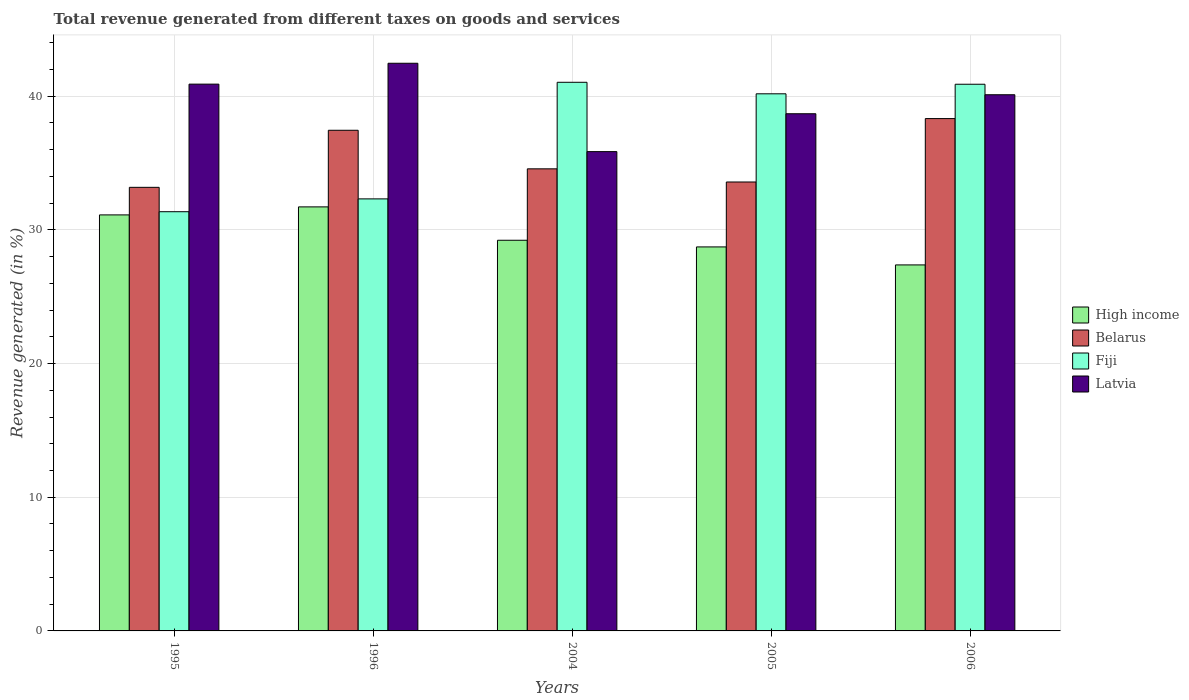How many groups of bars are there?
Make the answer very short. 5. How many bars are there on the 1st tick from the left?
Your answer should be compact. 4. How many bars are there on the 1st tick from the right?
Offer a terse response. 4. What is the total revenue generated in Latvia in 1995?
Ensure brevity in your answer.  40.9. Across all years, what is the maximum total revenue generated in High income?
Give a very brief answer. 31.72. Across all years, what is the minimum total revenue generated in Belarus?
Your answer should be very brief. 33.18. In which year was the total revenue generated in High income minimum?
Your answer should be very brief. 2006. What is the total total revenue generated in Belarus in the graph?
Offer a terse response. 177.1. What is the difference between the total revenue generated in Belarus in 1996 and that in 2006?
Provide a succinct answer. -0.88. What is the difference between the total revenue generated in Belarus in 1996 and the total revenue generated in Latvia in 2004?
Give a very brief answer. 1.6. What is the average total revenue generated in Belarus per year?
Your response must be concise. 35.42. In the year 2006, what is the difference between the total revenue generated in Latvia and total revenue generated in Fiji?
Your answer should be very brief. -0.79. In how many years, is the total revenue generated in High income greater than 6 %?
Ensure brevity in your answer.  5. What is the ratio of the total revenue generated in Fiji in 2005 to that in 2006?
Your answer should be very brief. 0.98. Is the total revenue generated in High income in 1995 less than that in 1996?
Ensure brevity in your answer.  Yes. Is the difference between the total revenue generated in Latvia in 2005 and 2006 greater than the difference between the total revenue generated in Fiji in 2005 and 2006?
Ensure brevity in your answer.  No. What is the difference between the highest and the second highest total revenue generated in Fiji?
Provide a succinct answer. 0.15. What is the difference between the highest and the lowest total revenue generated in High income?
Your response must be concise. 4.34. What does the 4th bar from the left in 1996 represents?
Give a very brief answer. Latvia. What does the 2nd bar from the right in 2004 represents?
Offer a terse response. Fiji. Is it the case that in every year, the sum of the total revenue generated in Fiji and total revenue generated in Latvia is greater than the total revenue generated in High income?
Offer a very short reply. Yes. How many bars are there?
Ensure brevity in your answer.  20. How many years are there in the graph?
Ensure brevity in your answer.  5. What is the difference between two consecutive major ticks on the Y-axis?
Offer a terse response. 10. Where does the legend appear in the graph?
Give a very brief answer. Center right. How many legend labels are there?
Provide a short and direct response. 4. What is the title of the graph?
Keep it short and to the point. Total revenue generated from different taxes on goods and services. Does "Greenland" appear as one of the legend labels in the graph?
Offer a terse response. No. What is the label or title of the Y-axis?
Make the answer very short. Revenue generated (in %). What is the Revenue generated (in %) of High income in 1995?
Provide a short and direct response. 31.12. What is the Revenue generated (in %) of Belarus in 1995?
Give a very brief answer. 33.18. What is the Revenue generated (in %) of Fiji in 1995?
Give a very brief answer. 31.36. What is the Revenue generated (in %) in Latvia in 1995?
Your answer should be compact. 40.9. What is the Revenue generated (in %) of High income in 1996?
Make the answer very short. 31.72. What is the Revenue generated (in %) in Belarus in 1996?
Your answer should be compact. 37.45. What is the Revenue generated (in %) of Fiji in 1996?
Your response must be concise. 32.32. What is the Revenue generated (in %) in Latvia in 1996?
Your response must be concise. 42.46. What is the Revenue generated (in %) in High income in 2004?
Make the answer very short. 29.22. What is the Revenue generated (in %) of Belarus in 2004?
Keep it short and to the point. 34.56. What is the Revenue generated (in %) in Fiji in 2004?
Your answer should be very brief. 41.04. What is the Revenue generated (in %) of Latvia in 2004?
Keep it short and to the point. 35.85. What is the Revenue generated (in %) of High income in 2005?
Provide a short and direct response. 28.72. What is the Revenue generated (in %) in Belarus in 2005?
Offer a very short reply. 33.58. What is the Revenue generated (in %) of Fiji in 2005?
Make the answer very short. 40.18. What is the Revenue generated (in %) of Latvia in 2005?
Make the answer very short. 38.69. What is the Revenue generated (in %) of High income in 2006?
Provide a succinct answer. 27.38. What is the Revenue generated (in %) of Belarus in 2006?
Provide a succinct answer. 38.32. What is the Revenue generated (in %) of Fiji in 2006?
Provide a succinct answer. 40.89. What is the Revenue generated (in %) in Latvia in 2006?
Your answer should be very brief. 40.11. Across all years, what is the maximum Revenue generated (in %) of High income?
Your answer should be very brief. 31.72. Across all years, what is the maximum Revenue generated (in %) of Belarus?
Offer a terse response. 38.32. Across all years, what is the maximum Revenue generated (in %) of Fiji?
Make the answer very short. 41.04. Across all years, what is the maximum Revenue generated (in %) of Latvia?
Make the answer very short. 42.46. Across all years, what is the minimum Revenue generated (in %) in High income?
Offer a terse response. 27.38. Across all years, what is the minimum Revenue generated (in %) of Belarus?
Make the answer very short. 33.18. Across all years, what is the minimum Revenue generated (in %) of Fiji?
Offer a very short reply. 31.36. Across all years, what is the minimum Revenue generated (in %) of Latvia?
Your response must be concise. 35.85. What is the total Revenue generated (in %) in High income in the graph?
Provide a succinct answer. 148.16. What is the total Revenue generated (in %) in Belarus in the graph?
Keep it short and to the point. 177.1. What is the total Revenue generated (in %) of Fiji in the graph?
Provide a short and direct response. 185.78. What is the total Revenue generated (in %) of Latvia in the graph?
Offer a terse response. 198.01. What is the difference between the Revenue generated (in %) in High income in 1995 and that in 1996?
Your answer should be very brief. -0.6. What is the difference between the Revenue generated (in %) of Belarus in 1995 and that in 1996?
Your answer should be very brief. -4.27. What is the difference between the Revenue generated (in %) of Fiji in 1995 and that in 1996?
Keep it short and to the point. -0.96. What is the difference between the Revenue generated (in %) in Latvia in 1995 and that in 1996?
Keep it short and to the point. -1.56. What is the difference between the Revenue generated (in %) in High income in 1995 and that in 2004?
Offer a terse response. 1.9. What is the difference between the Revenue generated (in %) in Belarus in 1995 and that in 2004?
Offer a terse response. -1.38. What is the difference between the Revenue generated (in %) of Fiji in 1995 and that in 2004?
Provide a succinct answer. -9.68. What is the difference between the Revenue generated (in %) in Latvia in 1995 and that in 2004?
Keep it short and to the point. 5.05. What is the difference between the Revenue generated (in %) in High income in 1995 and that in 2005?
Your response must be concise. 2.4. What is the difference between the Revenue generated (in %) in Belarus in 1995 and that in 2005?
Make the answer very short. -0.4. What is the difference between the Revenue generated (in %) of Fiji in 1995 and that in 2005?
Offer a very short reply. -8.82. What is the difference between the Revenue generated (in %) in Latvia in 1995 and that in 2005?
Ensure brevity in your answer.  2.21. What is the difference between the Revenue generated (in %) of High income in 1995 and that in 2006?
Provide a short and direct response. 3.74. What is the difference between the Revenue generated (in %) of Belarus in 1995 and that in 2006?
Your response must be concise. -5.14. What is the difference between the Revenue generated (in %) in Fiji in 1995 and that in 2006?
Provide a succinct answer. -9.53. What is the difference between the Revenue generated (in %) in Latvia in 1995 and that in 2006?
Your answer should be compact. 0.79. What is the difference between the Revenue generated (in %) of High income in 1996 and that in 2004?
Make the answer very short. 2.5. What is the difference between the Revenue generated (in %) in Belarus in 1996 and that in 2004?
Make the answer very short. 2.88. What is the difference between the Revenue generated (in %) in Fiji in 1996 and that in 2004?
Your answer should be compact. -8.72. What is the difference between the Revenue generated (in %) of Latvia in 1996 and that in 2004?
Ensure brevity in your answer.  6.61. What is the difference between the Revenue generated (in %) of High income in 1996 and that in 2005?
Provide a short and direct response. 2.99. What is the difference between the Revenue generated (in %) of Belarus in 1996 and that in 2005?
Give a very brief answer. 3.87. What is the difference between the Revenue generated (in %) of Fiji in 1996 and that in 2005?
Ensure brevity in your answer.  -7.86. What is the difference between the Revenue generated (in %) in Latvia in 1996 and that in 2005?
Make the answer very short. 3.78. What is the difference between the Revenue generated (in %) in High income in 1996 and that in 2006?
Your answer should be very brief. 4.34. What is the difference between the Revenue generated (in %) in Belarus in 1996 and that in 2006?
Provide a short and direct response. -0.88. What is the difference between the Revenue generated (in %) of Fiji in 1996 and that in 2006?
Give a very brief answer. -8.58. What is the difference between the Revenue generated (in %) of Latvia in 1996 and that in 2006?
Your answer should be compact. 2.35. What is the difference between the Revenue generated (in %) of High income in 2004 and that in 2005?
Offer a terse response. 0.5. What is the difference between the Revenue generated (in %) of Belarus in 2004 and that in 2005?
Keep it short and to the point. 0.98. What is the difference between the Revenue generated (in %) in Fiji in 2004 and that in 2005?
Ensure brevity in your answer.  0.86. What is the difference between the Revenue generated (in %) of Latvia in 2004 and that in 2005?
Ensure brevity in your answer.  -2.83. What is the difference between the Revenue generated (in %) in High income in 2004 and that in 2006?
Your answer should be compact. 1.84. What is the difference between the Revenue generated (in %) in Belarus in 2004 and that in 2006?
Make the answer very short. -3.76. What is the difference between the Revenue generated (in %) in Fiji in 2004 and that in 2006?
Offer a terse response. 0.15. What is the difference between the Revenue generated (in %) in Latvia in 2004 and that in 2006?
Offer a very short reply. -4.25. What is the difference between the Revenue generated (in %) in High income in 2005 and that in 2006?
Give a very brief answer. 1.35. What is the difference between the Revenue generated (in %) in Belarus in 2005 and that in 2006?
Provide a succinct answer. -4.74. What is the difference between the Revenue generated (in %) in Fiji in 2005 and that in 2006?
Give a very brief answer. -0.72. What is the difference between the Revenue generated (in %) of Latvia in 2005 and that in 2006?
Give a very brief answer. -1.42. What is the difference between the Revenue generated (in %) in High income in 1995 and the Revenue generated (in %) in Belarus in 1996?
Provide a succinct answer. -6.33. What is the difference between the Revenue generated (in %) of High income in 1995 and the Revenue generated (in %) of Fiji in 1996?
Offer a terse response. -1.2. What is the difference between the Revenue generated (in %) of High income in 1995 and the Revenue generated (in %) of Latvia in 1996?
Make the answer very short. -11.34. What is the difference between the Revenue generated (in %) of Belarus in 1995 and the Revenue generated (in %) of Fiji in 1996?
Offer a terse response. 0.86. What is the difference between the Revenue generated (in %) of Belarus in 1995 and the Revenue generated (in %) of Latvia in 1996?
Provide a short and direct response. -9.28. What is the difference between the Revenue generated (in %) of Fiji in 1995 and the Revenue generated (in %) of Latvia in 1996?
Give a very brief answer. -11.1. What is the difference between the Revenue generated (in %) of High income in 1995 and the Revenue generated (in %) of Belarus in 2004?
Make the answer very short. -3.45. What is the difference between the Revenue generated (in %) in High income in 1995 and the Revenue generated (in %) in Fiji in 2004?
Provide a short and direct response. -9.92. What is the difference between the Revenue generated (in %) in High income in 1995 and the Revenue generated (in %) in Latvia in 2004?
Keep it short and to the point. -4.73. What is the difference between the Revenue generated (in %) of Belarus in 1995 and the Revenue generated (in %) of Fiji in 2004?
Keep it short and to the point. -7.86. What is the difference between the Revenue generated (in %) of Belarus in 1995 and the Revenue generated (in %) of Latvia in 2004?
Make the answer very short. -2.67. What is the difference between the Revenue generated (in %) in Fiji in 1995 and the Revenue generated (in %) in Latvia in 2004?
Your answer should be very brief. -4.49. What is the difference between the Revenue generated (in %) in High income in 1995 and the Revenue generated (in %) in Belarus in 2005?
Your answer should be compact. -2.46. What is the difference between the Revenue generated (in %) in High income in 1995 and the Revenue generated (in %) in Fiji in 2005?
Your response must be concise. -9.06. What is the difference between the Revenue generated (in %) of High income in 1995 and the Revenue generated (in %) of Latvia in 2005?
Keep it short and to the point. -7.57. What is the difference between the Revenue generated (in %) in Belarus in 1995 and the Revenue generated (in %) in Fiji in 2005?
Your answer should be compact. -7. What is the difference between the Revenue generated (in %) in Belarus in 1995 and the Revenue generated (in %) in Latvia in 2005?
Ensure brevity in your answer.  -5.5. What is the difference between the Revenue generated (in %) of Fiji in 1995 and the Revenue generated (in %) of Latvia in 2005?
Give a very brief answer. -7.33. What is the difference between the Revenue generated (in %) of High income in 1995 and the Revenue generated (in %) of Belarus in 2006?
Ensure brevity in your answer.  -7.2. What is the difference between the Revenue generated (in %) in High income in 1995 and the Revenue generated (in %) in Fiji in 2006?
Make the answer very short. -9.77. What is the difference between the Revenue generated (in %) in High income in 1995 and the Revenue generated (in %) in Latvia in 2006?
Provide a short and direct response. -8.99. What is the difference between the Revenue generated (in %) of Belarus in 1995 and the Revenue generated (in %) of Fiji in 2006?
Ensure brevity in your answer.  -7.71. What is the difference between the Revenue generated (in %) of Belarus in 1995 and the Revenue generated (in %) of Latvia in 2006?
Make the answer very short. -6.93. What is the difference between the Revenue generated (in %) in Fiji in 1995 and the Revenue generated (in %) in Latvia in 2006?
Offer a very short reply. -8.75. What is the difference between the Revenue generated (in %) in High income in 1996 and the Revenue generated (in %) in Belarus in 2004?
Your answer should be very brief. -2.85. What is the difference between the Revenue generated (in %) of High income in 1996 and the Revenue generated (in %) of Fiji in 2004?
Offer a very short reply. -9.32. What is the difference between the Revenue generated (in %) of High income in 1996 and the Revenue generated (in %) of Latvia in 2004?
Your answer should be compact. -4.13. What is the difference between the Revenue generated (in %) in Belarus in 1996 and the Revenue generated (in %) in Fiji in 2004?
Offer a terse response. -3.59. What is the difference between the Revenue generated (in %) in Belarus in 1996 and the Revenue generated (in %) in Latvia in 2004?
Give a very brief answer. 1.6. What is the difference between the Revenue generated (in %) of Fiji in 1996 and the Revenue generated (in %) of Latvia in 2004?
Ensure brevity in your answer.  -3.54. What is the difference between the Revenue generated (in %) in High income in 1996 and the Revenue generated (in %) in Belarus in 2005?
Provide a succinct answer. -1.86. What is the difference between the Revenue generated (in %) in High income in 1996 and the Revenue generated (in %) in Fiji in 2005?
Give a very brief answer. -8.46. What is the difference between the Revenue generated (in %) in High income in 1996 and the Revenue generated (in %) in Latvia in 2005?
Offer a very short reply. -6.97. What is the difference between the Revenue generated (in %) in Belarus in 1996 and the Revenue generated (in %) in Fiji in 2005?
Your answer should be compact. -2.73. What is the difference between the Revenue generated (in %) in Belarus in 1996 and the Revenue generated (in %) in Latvia in 2005?
Provide a short and direct response. -1.24. What is the difference between the Revenue generated (in %) in Fiji in 1996 and the Revenue generated (in %) in Latvia in 2005?
Give a very brief answer. -6.37. What is the difference between the Revenue generated (in %) of High income in 1996 and the Revenue generated (in %) of Belarus in 2006?
Your response must be concise. -6.61. What is the difference between the Revenue generated (in %) in High income in 1996 and the Revenue generated (in %) in Fiji in 2006?
Make the answer very short. -9.17. What is the difference between the Revenue generated (in %) in High income in 1996 and the Revenue generated (in %) in Latvia in 2006?
Keep it short and to the point. -8.39. What is the difference between the Revenue generated (in %) in Belarus in 1996 and the Revenue generated (in %) in Fiji in 2006?
Make the answer very short. -3.44. What is the difference between the Revenue generated (in %) in Belarus in 1996 and the Revenue generated (in %) in Latvia in 2006?
Your response must be concise. -2.66. What is the difference between the Revenue generated (in %) in Fiji in 1996 and the Revenue generated (in %) in Latvia in 2006?
Give a very brief answer. -7.79. What is the difference between the Revenue generated (in %) in High income in 2004 and the Revenue generated (in %) in Belarus in 2005?
Ensure brevity in your answer.  -4.36. What is the difference between the Revenue generated (in %) of High income in 2004 and the Revenue generated (in %) of Fiji in 2005?
Your answer should be very brief. -10.95. What is the difference between the Revenue generated (in %) in High income in 2004 and the Revenue generated (in %) in Latvia in 2005?
Offer a very short reply. -9.46. What is the difference between the Revenue generated (in %) in Belarus in 2004 and the Revenue generated (in %) in Fiji in 2005?
Offer a very short reply. -5.61. What is the difference between the Revenue generated (in %) in Belarus in 2004 and the Revenue generated (in %) in Latvia in 2005?
Offer a very short reply. -4.12. What is the difference between the Revenue generated (in %) of Fiji in 2004 and the Revenue generated (in %) of Latvia in 2005?
Make the answer very short. 2.35. What is the difference between the Revenue generated (in %) in High income in 2004 and the Revenue generated (in %) in Belarus in 2006?
Your response must be concise. -9.1. What is the difference between the Revenue generated (in %) of High income in 2004 and the Revenue generated (in %) of Fiji in 2006?
Keep it short and to the point. -11.67. What is the difference between the Revenue generated (in %) of High income in 2004 and the Revenue generated (in %) of Latvia in 2006?
Offer a terse response. -10.88. What is the difference between the Revenue generated (in %) in Belarus in 2004 and the Revenue generated (in %) in Fiji in 2006?
Make the answer very short. -6.33. What is the difference between the Revenue generated (in %) in Belarus in 2004 and the Revenue generated (in %) in Latvia in 2006?
Your response must be concise. -5.54. What is the difference between the Revenue generated (in %) in Fiji in 2004 and the Revenue generated (in %) in Latvia in 2006?
Ensure brevity in your answer.  0.93. What is the difference between the Revenue generated (in %) in High income in 2005 and the Revenue generated (in %) in Belarus in 2006?
Your answer should be very brief. -9.6. What is the difference between the Revenue generated (in %) in High income in 2005 and the Revenue generated (in %) in Fiji in 2006?
Provide a short and direct response. -12.17. What is the difference between the Revenue generated (in %) of High income in 2005 and the Revenue generated (in %) of Latvia in 2006?
Provide a succinct answer. -11.38. What is the difference between the Revenue generated (in %) in Belarus in 2005 and the Revenue generated (in %) in Fiji in 2006?
Ensure brevity in your answer.  -7.31. What is the difference between the Revenue generated (in %) in Belarus in 2005 and the Revenue generated (in %) in Latvia in 2006?
Keep it short and to the point. -6.53. What is the difference between the Revenue generated (in %) of Fiji in 2005 and the Revenue generated (in %) of Latvia in 2006?
Provide a short and direct response. 0.07. What is the average Revenue generated (in %) in High income per year?
Provide a short and direct response. 29.63. What is the average Revenue generated (in %) in Belarus per year?
Keep it short and to the point. 35.42. What is the average Revenue generated (in %) in Fiji per year?
Keep it short and to the point. 37.16. What is the average Revenue generated (in %) of Latvia per year?
Your response must be concise. 39.6. In the year 1995, what is the difference between the Revenue generated (in %) of High income and Revenue generated (in %) of Belarus?
Your answer should be compact. -2.06. In the year 1995, what is the difference between the Revenue generated (in %) in High income and Revenue generated (in %) in Fiji?
Your answer should be compact. -0.24. In the year 1995, what is the difference between the Revenue generated (in %) of High income and Revenue generated (in %) of Latvia?
Ensure brevity in your answer.  -9.78. In the year 1995, what is the difference between the Revenue generated (in %) of Belarus and Revenue generated (in %) of Fiji?
Provide a succinct answer. 1.82. In the year 1995, what is the difference between the Revenue generated (in %) in Belarus and Revenue generated (in %) in Latvia?
Offer a terse response. -7.72. In the year 1995, what is the difference between the Revenue generated (in %) of Fiji and Revenue generated (in %) of Latvia?
Your answer should be very brief. -9.54. In the year 1996, what is the difference between the Revenue generated (in %) in High income and Revenue generated (in %) in Belarus?
Make the answer very short. -5.73. In the year 1996, what is the difference between the Revenue generated (in %) in High income and Revenue generated (in %) in Fiji?
Your response must be concise. -0.6. In the year 1996, what is the difference between the Revenue generated (in %) of High income and Revenue generated (in %) of Latvia?
Your answer should be very brief. -10.74. In the year 1996, what is the difference between the Revenue generated (in %) of Belarus and Revenue generated (in %) of Fiji?
Make the answer very short. 5.13. In the year 1996, what is the difference between the Revenue generated (in %) in Belarus and Revenue generated (in %) in Latvia?
Your answer should be compact. -5.01. In the year 1996, what is the difference between the Revenue generated (in %) in Fiji and Revenue generated (in %) in Latvia?
Make the answer very short. -10.15. In the year 2004, what is the difference between the Revenue generated (in %) in High income and Revenue generated (in %) in Belarus?
Make the answer very short. -5.34. In the year 2004, what is the difference between the Revenue generated (in %) of High income and Revenue generated (in %) of Fiji?
Offer a very short reply. -11.82. In the year 2004, what is the difference between the Revenue generated (in %) in High income and Revenue generated (in %) in Latvia?
Your answer should be compact. -6.63. In the year 2004, what is the difference between the Revenue generated (in %) of Belarus and Revenue generated (in %) of Fiji?
Keep it short and to the point. -6.47. In the year 2004, what is the difference between the Revenue generated (in %) in Belarus and Revenue generated (in %) in Latvia?
Provide a succinct answer. -1.29. In the year 2004, what is the difference between the Revenue generated (in %) of Fiji and Revenue generated (in %) of Latvia?
Give a very brief answer. 5.19. In the year 2005, what is the difference between the Revenue generated (in %) of High income and Revenue generated (in %) of Belarus?
Give a very brief answer. -4.86. In the year 2005, what is the difference between the Revenue generated (in %) of High income and Revenue generated (in %) of Fiji?
Ensure brevity in your answer.  -11.45. In the year 2005, what is the difference between the Revenue generated (in %) in High income and Revenue generated (in %) in Latvia?
Your response must be concise. -9.96. In the year 2005, what is the difference between the Revenue generated (in %) of Belarus and Revenue generated (in %) of Fiji?
Offer a very short reply. -6.6. In the year 2005, what is the difference between the Revenue generated (in %) of Belarus and Revenue generated (in %) of Latvia?
Keep it short and to the point. -5.11. In the year 2005, what is the difference between the Revenue generated (in %) in Fiji and Revenue generated (in %) in Latvia?
Offer a very short reply. 1.49. In the year 2006, what is the difference between the Revenue generated (in %) of High income and Revenue generated (in %) of Belarus?
Your answer should be very brief. -10.95. In the year 2006, what is the difference between the Revenue generated (in %) in High income and Revenue generated (in %) in Fiji?
Offer a terse response. -13.51. In the year 2006, what is the difference between the Revenue generated (in %) of High income and Revenue generated (in %) of Latvia?
Provide a succinct answer. -12.73. In the year 2006, what is the difference between the Revenue generated (in %) of Belarus and Revenue generated (in %) of Fiji?
Your answer should be compact. -2.57. In the year 2006, what is the difference between the Revenue generated (in %) in Belarus and Revenue generated (in %) in Latvia?
Your answer should be compact. -1.78. In the year 2006, what is the difference between the Revenue generated (in %) in Fiji and Revenue generated (in %) in Latvia?
Provide a short and direct response. 0.79. What is the ratio of the Revenue generated (in %) of High income in 1995 to that in 1996?
Make the answer very short. 0.98. What is the ratio of the Revenue generated (in %) in Belarus in 1995 to that in 1996?
Your answer should be compact. 0.89. What is the ratio of the Revenue generated (in %) in Fiji in 1995 to that in 1996?
Keep it short and to the point. 0.97. What is the ratio of the Revenue generated (in %) in Latvia in 1995 to that in 1996?
Your answer should be compact. 0.96. What is the ratio of the Revenue generated (in %) of High income in 1995 to that in 2004?
Provide a short and direct response. 1.06. What is the ratio of the Revenue generated (in %) of Fiji in 1995 to that in 2004?
Make the answer very short. 0.76. What is the ratio of the Revenue generated (in %) in Latvia in 1995 to that in 2004?
Provide a succinct answer. 1.14. What is the ratio of the Revenue generated (in %) in High income in 1995 to that in 2005?
Your answer should be compact. 1.08. What is the ratio of the Revenue generated (in %) of Belarus in 1995 to that in 2005?
Keep it short and to the point. 0.99. What is the ratio of the Revenue generated (in %) in Fiji in 1995 to that in 2005?
Make the answer very short. 0.78. What is the ratio of the Revenue generated (in %) of Latvia in 1995 to that in 2005?
Your response must be concise. 1.06. What is the ratio of the Revenue generated (in %) of High income in 1995 to that in 2006?
Your answer should be compact. 1.14. What is the ratio of the Revenue generated (in %) of Belarus in 1995 to that in 2006?
Your answer should be compact. 0.87. What is the ratio of the Revenue generated (in %) of Fiji in 1995 to that in 2006?
Your response must be concise. 0.77. What is the ratio of the Revenue generated (in %) in Latvia in 1995 to that in 2006?
Your response must be concise. 1.02. What is the ratio of the Revenue generated (in %) in High income in 1996 to that in 2004?
Your response must be concise. 1.09. What is the ratio of the Revenue generated (in %) in Belarus in 1996 to that in 2004?
Ensure brevity in your answer.  1.08. What is the ratio of the Revenue generated (in %) of Fiji in 1996 to that in 2004?
Provide a succinct answer. 0.79. What is the ratio of the Revenue generated (in %) in Latvia in 1996 to that in 2004?
Your response must be concise. 1.18. What is the ratio of the Revenue generated (in %) in High income in 1996 to that in 2005?
Ensure brevity in your answer.  1.1. What is the ratio of the Revenue generated (in %) of Belarus in 1996 to that in 2005?
Your answer should be very brief. 1.12. What is the ratio of the Revenue generated (in %) of Fiji in 1996 to that in 2005?
Provide a short and direct response. 0.8. What is the ratio of the Revenue generated (in %) in Latvia in 1996 to that in 2005?
Ensure brevity in your answer.  1.1. What is the ratio of the Revenue generated (in %) in High income in 1996 to that in 2006?
Offer a very short reply. 1.16. What is the ratio of the Revenue generated (in %) of Belarus in 1996 to that in 2006?
Keep it short and to the point. 0.98. What is the ratio of the Revenue generated (in %) of Fiji in 1996 to that in 2006?
Keep it short and to the point. 0.79. What is the ratio of the Revenue generated (in %) in Latvia in 1996 to that in 2006?
Make the answer very short. 1.06. What is the ratio of the Revenue generated (in %) of High income in 2004 to that in 2005?
Ensure brevity in your answer.  1.02. What is the ratio of the Revenue generated (in %) in Belarus in 2004 to that in 2005?
Ensure brevity in your answer.  1.03. What is the ratio of the Revenue generated (in %) of Fiji in 2004 to that in 2005?
Keep it short and to the point. 1.02. What is the ratio of the Revenue generated (in %) of Latvia in 2004 to that in 2005?
Your answer should be very brief. 0.93. What is the ratio of the Revenue generated (in %) of High income in 2004 to that in 2006?
Provide a succinct answer. 1.07. What is the ratio of the Revenue generated (in %) of Belarus in 2004 to that in 2006?
Provide a succinct answer. 0.9. What is the ratio of the Revenue generated (in %) of Fiji in 2004 to that in 2006?
Your answer should be compact. 1. What is the ratio of the Revenue generated (in %) of Latvia in 2004 to that in 2006?
Keep it short and to the point. 0.89. What is the ratio of the Revenue generated (in %) in High income in 2005 to that in 2006?
Your answer should be very brief. 1.05. What is the ratio of the Revenue generated (in %) in Belarus in 2005 to that in 2006?
Offer a very short reply. 0.88. What is the ratio of the Revenue generated (in %) of Fiji in 2005 to that in 2006?
Provide a succinct answer. 0.98. What is the ratio of the Revenue generated (in %) in Latvia in 2005 to that in 2006?
Provide a short and direct response. 0.96. What is the difference between the highest and the second highest Revenue generated (in %) of High income?
Ensure brevity in your answer.  0.6. What is the difference between the highest and the second highest Revenue generated (in %) in Belarus?
Your response must be concise. 0.88. What is the difference between the highest and the second highest Revenue generated (in %) in Fiji?
Provide a short and direct response. 0.15. What is the difference between the highest and the second highest Revenue generated (in %) of Latvia?
Your answer should be compact. 1.56. What is the difference between the highest and the lowest Revenue generated (in %) of High income?
Keep it short and to the point. 4.34. What is the difference between the highest and the lowest Revenue generated (in %) in Belarus?
Your answer should be very brief. 5.14. What is the difference between the highest and the lowest Revenue generated (in %) in Fiji?
Ensure brevity in your answer.  9.68. What is the difference between the highest and the lowest Revenue generated (in %) in Latvia?
Offer a terse response. 6.61. 